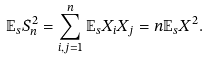Convert formula to latex. <formula><loc_0><loc_0><loc_500><loc_500>\mathbb { E } _ { s } S _ { n } ^ { 2 } = \sum _ { i , j = 1 } ^ { n } \mathbb { E } _ { s } X _ { i } X _ { j } = n \mathbb { E } _ { s } X ^ { 2 } .</formula> 